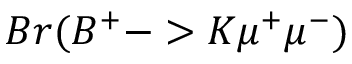Convert formula to latex. <formula><loc_0><loc_0><loc_500><loc_500>B r ( B ^ { + } - > K \mu ^ { + } \mu ^ { - } )</formula> 